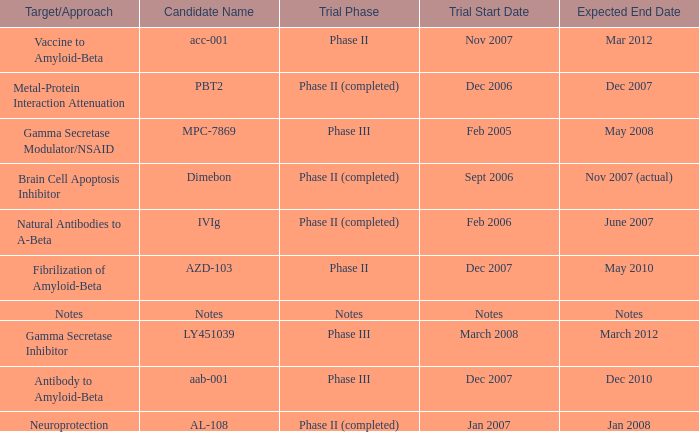What is Trial Start Date, when Candidate Name is Notes? Notes. 